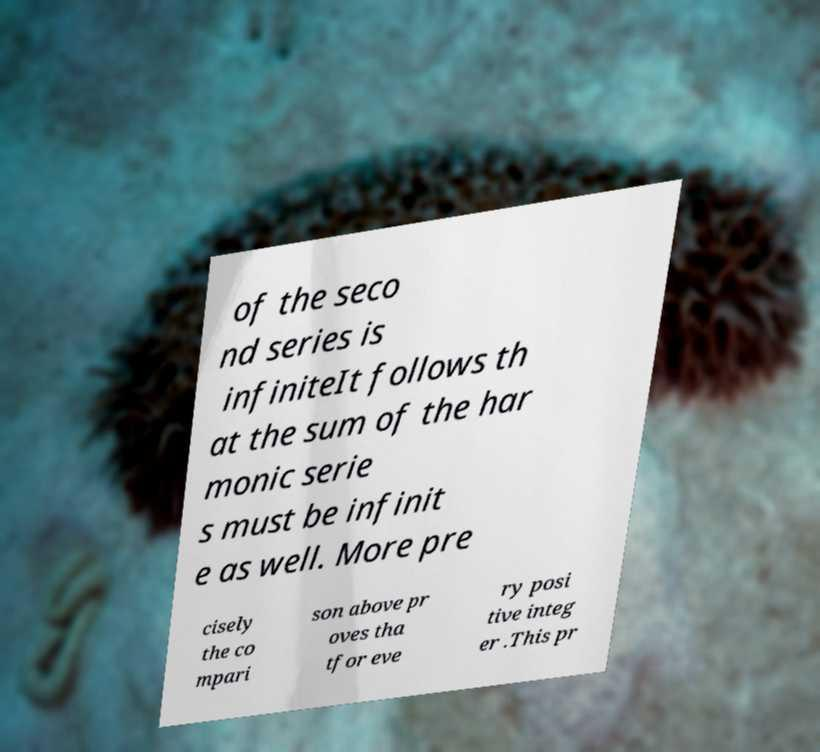For documentation purposes, I need the text within this image transcribed. Could you provide that? of the seco nd series is infiniteIt follows th at the sum of the har monic serie s must be infinit e as well. More pre cisely the co mpari son above pr oves tha tfor eve ry posi tive integ er .This pr 